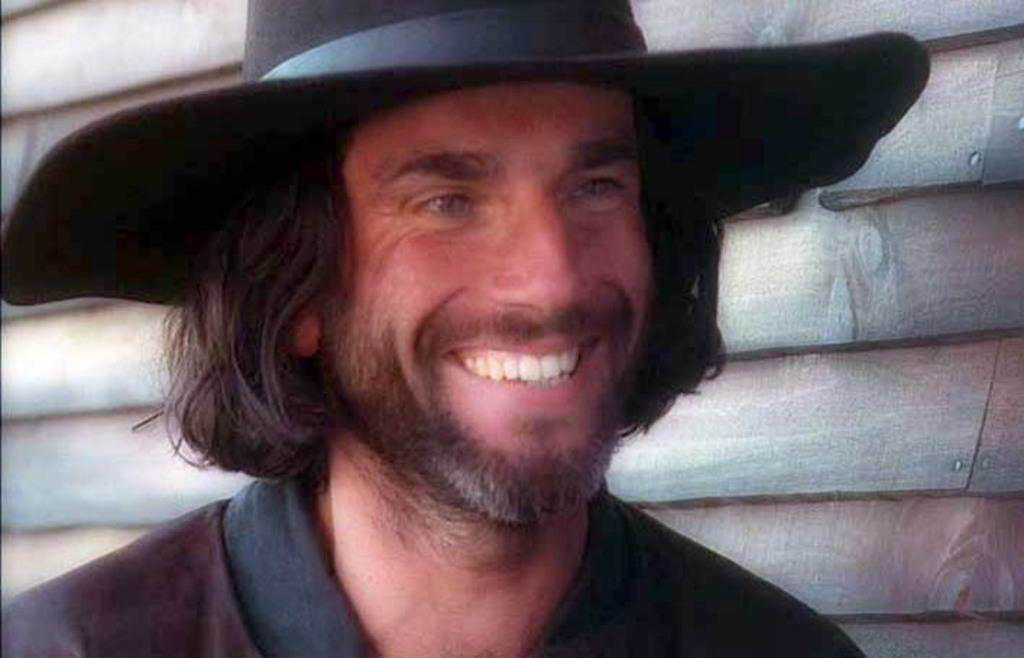What is the main subject of the image? There is a person in the image. What is the person wearing on their head? The person is wearing a hat. What is the person's facial expression in the image? The person is smiling. Can you describe the background of the image? There is a wooden background in the image. What type of cart can be seen in the image? There is no cart present in the image; it features a person wearing a hat and smiling against a wooden background. How many coaches are visible in the image? There are no coaches present in the image. 